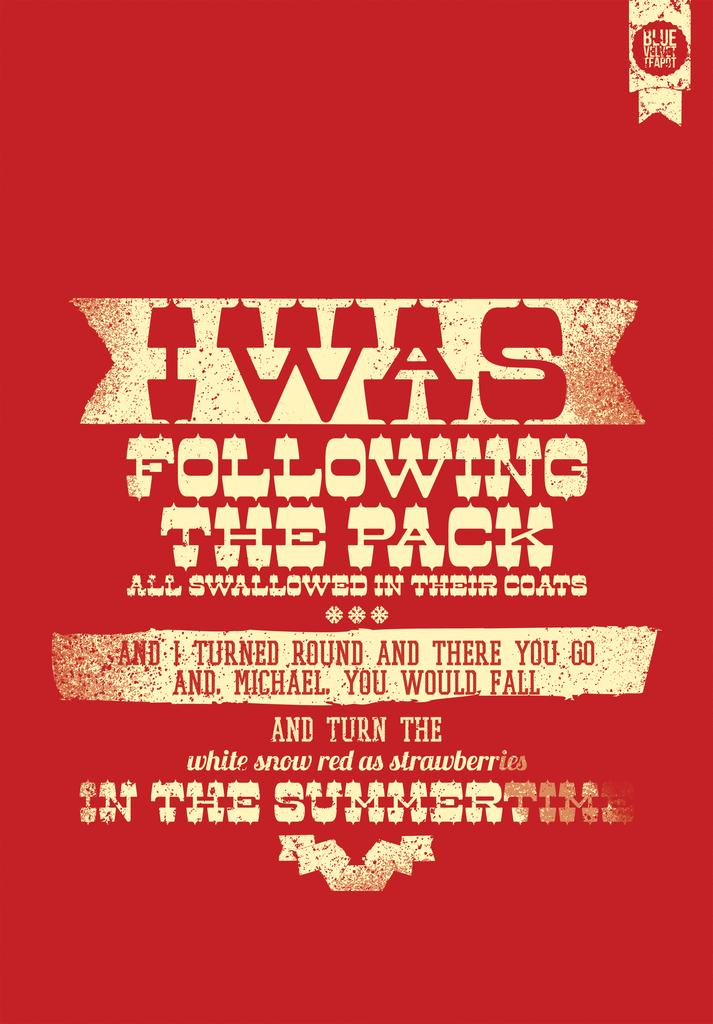<image>
Render a clear and concise summary of the photo. A red poster has a message on it that says, "I was following the pack". 